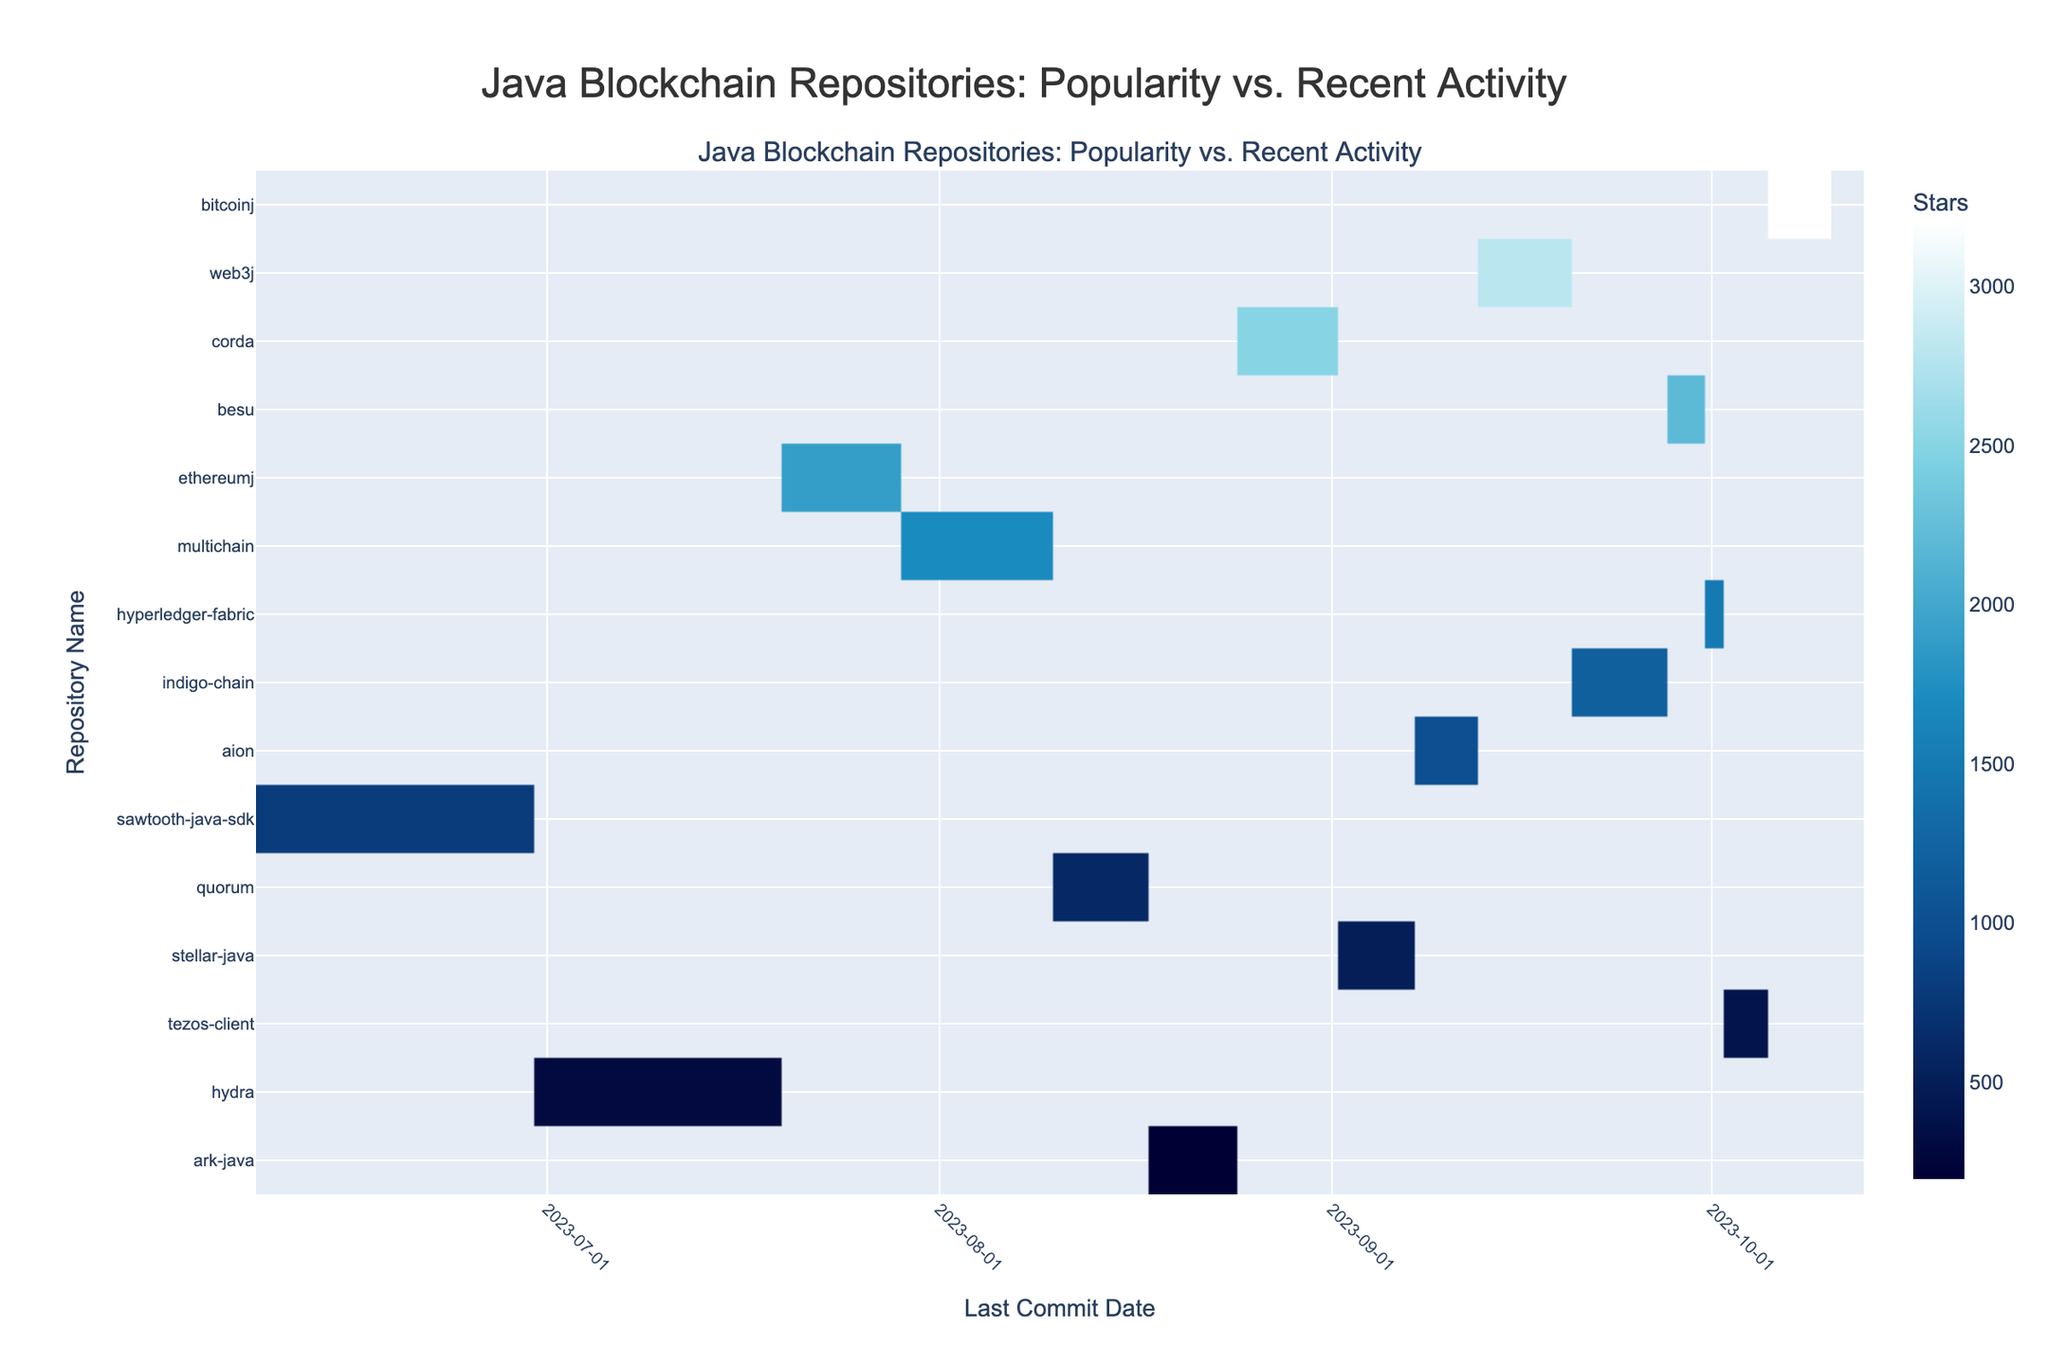What is the title of the heatmap? The title is usually written at the top of the chart. In this case, it should be "Java Blockchain Repositories: Popularity vs. Recent Activity" based on the code provided.
Answer: Java Blockchain Repositories: Popularity vs. Recent Activity Which repository has the highest number of stars? The repository with the highest number of stars will have the highest intensity (darkest color) in the heatmap. Based on the data, it should be "bitcoinj" with 3200 stars.
Answer: bitcoinj What is the last commit date for the repository "hyperledger-fabric"? To find the last commit date for "hyperledger-fabric," locate the corresponding y-axis label and trace horizontally to the date on the x-axis. Based on the data, it was on 2023-10-01.
Answer: 2023-10-01 How many repositories have more than 2000 stars? Identify the number of data points (repositories) that have a star count greater than 2000 by looking at the color intensity and the star count in the hover information. From the data, there are four such repositories: bitcoinj, web3j, corda, and besu.
Answer: 4 Which repository had the most recent commit? The most recent commit will be the rightmost point on the x-axis. According to the data, it should be "bitcoinj" with a commit on 2023-10-08.
Answer: bitcoinj What is the date range shown on the x-axis? Observe the start and end dates on the x-axis to determine the range. The code suggests the minimum date minus 5 days and the maximum date plus 5 days, which translates to a range from 2023-06-08 to 2023-10-13.
Answer: 2023-06-08 to 2023-10-13 Which repository with less than 1000 stars had the most recent commit? To find this, look for repositories with star counts less than 1000 and then find the one with the commit date closest to the rightmost part of the x-axis. According to the data, "tezos-client" with 400 stars committed on 2023-10-03 fits this criteria.
Answer: tezos-client How many repositories have a last commit date before September 2023? Identify the x-axis ticks corresponding to dates before September 2023 and count the repositories that fall under this date range. Based on the data, ethereumj, multichain, sawtooth-java-sdk, quorum, hydra, and ark-java fit this criteria, totaling to six.
Answer: 6 Which repository had a commit after "indigo-chain" but before "corda"? Locate the dates of the last commit for "indigo-chain" (2023-09-25) and "corda" (2023-08-29), then identify the repository with a commit date between these two. "aion" with a commit date of 2023-09-10 and "web3j" with a commit date of 2023-09-15 fit this criteria.
Answer: aion, web3j 